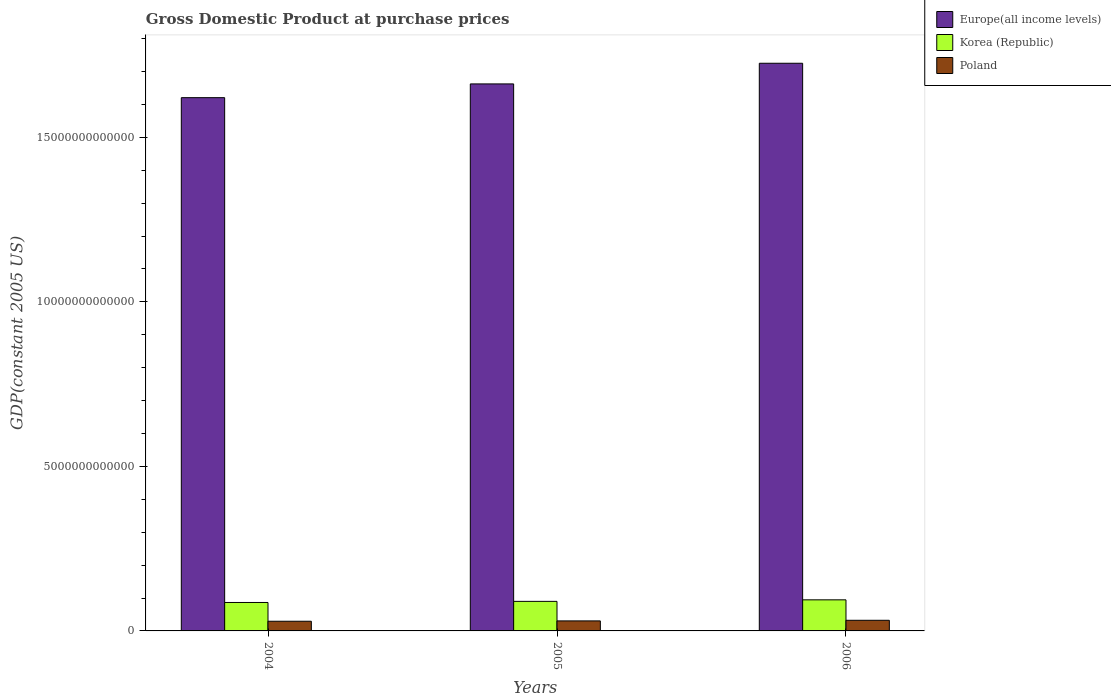How many groups of bars are there?
Provide a short and direct response. 3. How many bars are there on the 2nd tick from the left?
Ensure brevity in your answer.  3. How many bars are there on the 3rd tick from the right?
Your response must be concise. 3. What is the GDP at purchase prices in Europe(all income levels) in 2005?
Give a very brief answer. 1.66e+13. Across all years, what is the maximum GDP at purchase prices in Poland?
Offer a very short reply. 3.23e+11. Across all years, what is the minimum GDP at purchase prices in Korea (Republic)?
Your answer should be very brief. 8.64e+11. What is the total GDP at purchase prices in Korea (Republic) in the graph?
Provide a short and direct response. 2.71e+12. What is the difference between the GDP at purchase prices in Europe(all income levels) in 2004 and that in 2005?
Offer a terse response. -4.18e+11. What is the difference between the GDP at purchase prices in Poland in 2005 and the GDP at purchase prices in Europe(all income levels) in 2004?
Provide a succinct answer. -1.59e+13. What is the average GDP at purchase prices in Korea (Republic) per year?
Keep it short and to the point. 9.02e+11. In the year 2005, what is the difference between the GDP at purchase prices in Korea (Republic) and GDP at purchase prices in Poland?
Make the answer very short. 5.94e+11. What is the ratio of the GDP at purchase prices in Poland in 2004 to that in 2006?
Your answer should be very brief. 0.91. What is the difference between the highest and the second highest GDP at purchase prices in Europe(all income levels)?
Provide a succinct answer. 6.28e+11. What is the difference between the highest and the lowest GDP at purchase prices in Europe(all income levels)?
Your response must be concise. 1.05e+12. Is the sum of the GDP at purchase prices in Poland in 2005 and 2006 greater than the maximum GDP at purchase prices in Korea (Republic) across all years?
Keep it short and to the point. No. What does the 1st bar from the right in 2004 represents?
Keep it short and to the point. Poland. How many bars are there?
Your answer should be very brief. 9. Are all the bars in the graph horizontal?
Keep it short and to the point. No. How many years are there in the graph?
Ensure brevity in your answer.  3. What is the difference between two consecutive major ticks on the Y-axis?
Offer a terse response. 5.00e+12. How many legend labels are there?
Your response must be concise. 3. What is the title of the graph?
Offer a very short reply. Gross Domestic Product at purchase prices. What is the label or title of the Y-axis?
Your response must be concise. GDP(constant 2005 US). What is the GDP(constant 2005 US) of Europe(all income levels) in 2004?
Your answer should be compact. 1.62e+13. What is the GDP(constant 2005 US) of Korea (Republic) in 2004?
Your response must be concise. 8.64e+11. What is the GDP(constant 2005 US) in Poland in 2004?
Make the answer very short. 2.94e+11. What is the GDP(constant 2005 US) of Europe(all income levels) in 2005?
Ensure brevity in your answer.  1.66e+13. What is the GDP(constant 2005 US) in Korea (Republic) in 2005?
Offer a very short reply. 8.98e+11. What is the GDP(constant 2005 US) in Poland in 2005?
Your answer should be very brief. 3.04e+11. What is the GDP(constant 2005 US) of Europe(all income levels) in 2006?
Provide a short and direct response. 1.73e+13. What is the GDP(constant 2005 US) in Korea (Republic) in 2006?
Your answer should be compact. 9.45e+11. What is the GDP(constant 2005 US) in Poland in 2006?
Make the answer very short. 3.23e+11. Across all years, what is the maximum GDP(constant 2005 US) of Europe(all income levels)?
Provide a succinct answer. 1.73e+13. Across all years, what is the maximum GDP(constant 2005 US) in Korea (Republic)?
Your response must be concise. 9.45e+11. Across all years, what is the maximum GDP(constant 2005 US) in Poland?
Ensure brevity in your answer.  3.23e+11. Across all years, what is the minimum GDP(constant 2005 US) of Europe(all income levels)?
Ensure brevity in your answer.  1.62e+13. Across all years, what is the minimum GDP(constant 2005 US) of Korea (Republic)?
Keep it short and to the point. 8.64e+11. Across all years, what is the minimum GDP(constant 2005 US) in Poland?
Offer a terse response. 2.94e+11. What is the total GDP(constant 2005 US) in Europe(all income levels) in the graph?
Offer a very short reply. 5.01e+13. What is the total GDP(constant 2005 US) in Korea (Republic) in the graph?
Your answer should be compact. 2.71e+12. What is the total GDP(constant 2005 US) in Poland in the graph?
Offer a terse response. 9.22e+11. What is the difference between the GDP(constant 2005 US) of Europe(all income levels) in 2004 and that in 2005?
Provide a succinct answer. -4.18e+11. What is the difference between the GDP(constant 2005 US) in Korea (Republic) in 2004 and that in 2005?
Offer a terse response. -3.39e+1. What is the difference between the GDP(constant 2005 US) in Poland in 2004 and that in 2005?
Provide a short and direct response. -1.04e+1. What is the difference between the GDP(constant 2005 US) of Europe(all income levels) in 2004 and that in 2006?
Provide a short and direct response. -1.05e+12. What is the difference between the GDP(constant 2005 US) of Korea (Republic) in 2004 and that in 2006?
Provide a succinct answer. -8.04e+1. What is the difference between the GDP(constant 2005 US) of Poland in 2004 and that in 2006?
Ensure brevity in your answer.  -2.93e+1. What is the difference between the GDP(constant 2005 US) of Europe(all income levels) in 2005 and that in 2006?
Provide a short and direct response. -6.28e+11. What is the difference between the GDP(constant 2005 US) of Korea (Republic) in 2005 and that in 2006?
Your answer should be very brief. -4.65e+1. What is the difference between the GDP(constant 2005 US) in Poland in 2005 and that in 2006?
Your response must be concise. -1.89e+1. What is the difference between the GDP(constant 2005 US) of Europe(all income levels) in 2004 and the GDP(constant 2005 US) of Korea (Republic) in 2005?
Your answer should be compact. 1.53e+13. What is the difference between the GDP(constant 2005 US) in Europe(all income levels) in 2004 and the GDP(constant 2005 US) in Poland in 2005?
Keep it short and to the point. 1.59e+13. What is the difference between the GDP(constant 2005 US) in Korea (Republic) in 2004 and the GDP(constant 2005 US) in Poland in 2005?
Your response must be concise. 5.60e+11. What is the difference between the GDP(constant 2005 US) of Europe(all income levels) in 2004 and the GDP(constant 2005 US) of Korea (Republic) in 2006?
Provide a short and direct response. 1.53e+13. What is the difference between the GDP(constant 2005 US) in Europe(all income levels) in 2004 and the GDP(constant 2005 US) in Poland in 2006?
Your answer should be very brief. 1.59e+13. What is the difference between the GDP(constant 2005 US) in Korea (Republic) in 2004 and the GDP(constant 2005 US) in Poland in 2006?
Provide a short and direct response. 5.41e+11. What is the difference between the GDP(constant 2005 US) of Europe(all income levels) in 2005 and the GDP(constant 2005 US) of Korea (Republic) in 2006?
Your answer should be very brief. 1.57e+13. What is the difference between the GDP(constant 2005 US) of Europe(all income levels) in 2005 and the GDP(constant 2005 US) of Poland in 2006?
Give a very brief answer. 1.63e+13. What is the difference between the GDP(constant 2005 US) in Korea (Republic) in 2005 and the GDP(constant 2005 US) in Poland in 2006?
Give a very brief answer. 5.75e+11. What is the average GDP(constant 2005 US) of Europe(all income levels) per year?
Your answer should be very brief. 1.67e+13. What is the average GDP(constant 2005 US) in Korea (Republic) per year?
Make the answer very short. 9.02e+11. What is the average GDP(constant 2005 US) of Poland per year?
Your answer should be very brief. 3.07e+11. In the year 2004, what is the difference between the GDP(constant 2005 US) of Europe(all income levels) and GDP(constant 2005 US) of Korea (Republic)?
Keep it short and to the point. 1.53e+13. In the year 2004, what is the difference between the GDP(constant 2005 US) of Europe(all income levels) and GDP(constant 2005 US) of Poland?
Your response must be concise. 1.59e+13. In the year 2004, what is the difference between the GDP(constant 2005 US) in Korea (Republic) and GDP(constant 2005 US) in Poland?
Keep it short and to the point. 5.70e+11. In the year 2005, what is the difference between the GDP(constant 2005 US) in Europe(all income levels) and GDP(constant 2005 US) in Korea (Republic)?
Offer a terse response. 1.57e+13. In the year 2005, what is the difference between the GDP(constant 2005 US) in Europe(all income levels) and GDP(constant 2005 US) in Poland?
Your answer should be very brief. 1.63e+13. In the year 2005, what is the difference between the GDP(constant 2005 US) in Korea (Republic) and GDP(constant 2005 US) in Poland?
Your answer should be very brief. 5.94e+11. In the year 2006, what is the difference between the GDP(constant 2005 US) in Europe(all income levels) and GDP(constant 2005 US) in Korea (Republic)?
Make the answer very short. 1.63e+13. In the year 2006, what is the difference between the GDP(constant 2005 US) in Europe(all income levels) and GDP(constant 2005 US) in Poland?
Make the answer very short. 1.69e+13. In the year 2006, what is the difference between the GDP(constant 2005 US) of Korea (Republic) and GDP(constant 2005 US) of Poland?
Your answer should be very brief. 6.21e+11. What is the ratio of the GDP(constant 2005 US) in Europe(all income levels) in 2004 to that in 2005?
Your response must be concise. 0.97. What is the ratio of the GDP(constant 2005 US) of Korea (Republic) in 2004 to that in 2005?
Your answer should be compact. 0.96. What is the ratio of the GDP(constant 2005 US) in Poland in 2004 to that in 2005?
Keep it short and to the point. 0.97. What is the ratio of the GDP(constant 2005 US) in Europe(all income levels) in 2004 to that in 2006?
Provide a short and direct response. 0.94. What is the ratio of the GDP(constant 2005 US) in Korea (Republic) in 2004 to that in 2006?
Offer a very short reply. 0.91. What is the ratio of the GDP(constant 2005 US) in Poland in 2004 to that in 2006?
Ensure brevity in your answer.  0.91. What is the ratio of the GDP(constant 2005 US) in Europe(all income levels) in 2005 to that in 2006?
Your answer should be very brief. 0.96. What is the ratio of the GDP(constant 2005 US) of Korea (Republic) in 2005 to that in 2006?
Keep it short and to the point. 0.95. What is the ratio of the GDP(constant 2005 US) of Poland in 2005 to that in 2006?
Your response must be concise. 0.94. What is the difference between the highest and the second highest GDP(constant 2005 US) in Europe(all income levels)?
Give a very brief answer. 6.28e+11. What is the difference between the highest and the second highest GDP(constant 2005 US) of Korea (Republic)?
Offer a very short reply. 4.65e+1. What is the difference between the highest and the second highest GDP(constant 2005 US) in Poland?
Your answer should be compact. 1.89e+1. What is the difference between the highest and the lowest GDP(constant 2005 US) of Europe(all income levels)?
Make the answer very short. 1.05e+12. What is the difference between the highest and the lowest GDP(constant 2005 US) in Korea (Republic)?
Provide a succinct answer. 8.04e+1. What is the difference between the highest and the lowest GDP(constant 2005 US) in Poland?
Your response must be concise. 2.93e+1. 